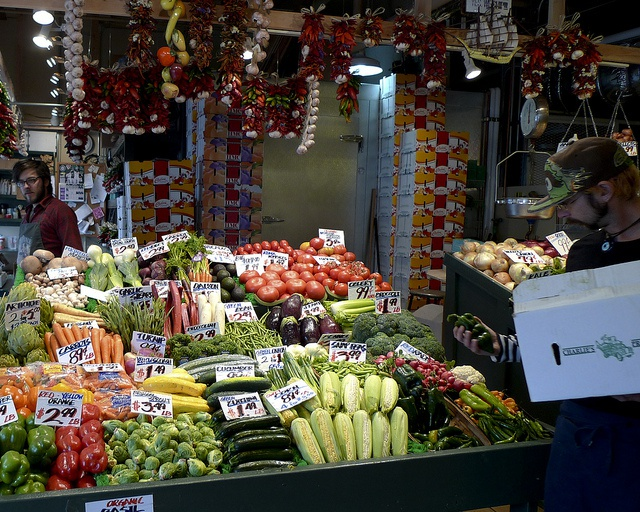Describe the objects in this image and their specific colors. I can see people in gray, black, and darkgreen tones, carrot in gray, tan, white, brown, and khaki tones, people in gray, black, and maroon tones, broccoli in gray, black, and darkgreen tones, and carrot in gray, tan, red, and salmon tones in this image. 